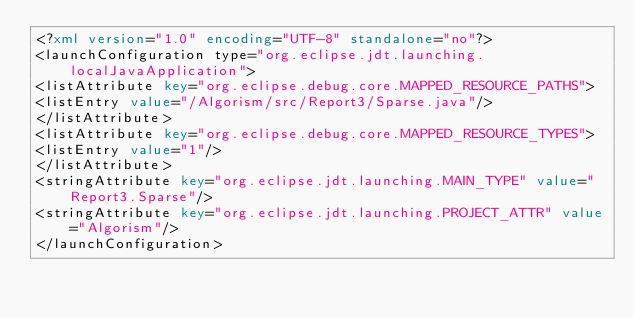<code> <loc_0><loc_0><loc_500><loc_500><_XML_><?xml version="1.0" encoding="UTF-8" standalone="no"?>
<launchConfiguration type="org.eclipse.jdt.launching.localJavaApplication">
<listAttribute key="org.eclipse.debug.core.MAPPED_RESOURCE_PATHS">
<listEntry value="/Algorism/src/Report3/Sparse.java"/>
</listAttribute>
<listAttribute key="org.eclipse.debug.core.MAPPED_RESOURCE_TYPES">
<listEntry value="1"/>
</listAttribute>
<stringAttribute key="org.eclipse.jdt.launching.MAIN_TYPE" value="Report3.Sparse"/>
<stringAttribute key="org.eclipse.jdt.launching.PROJECT_ATTR" value="Algorism"/>
</launchConfiguration>
</code> 